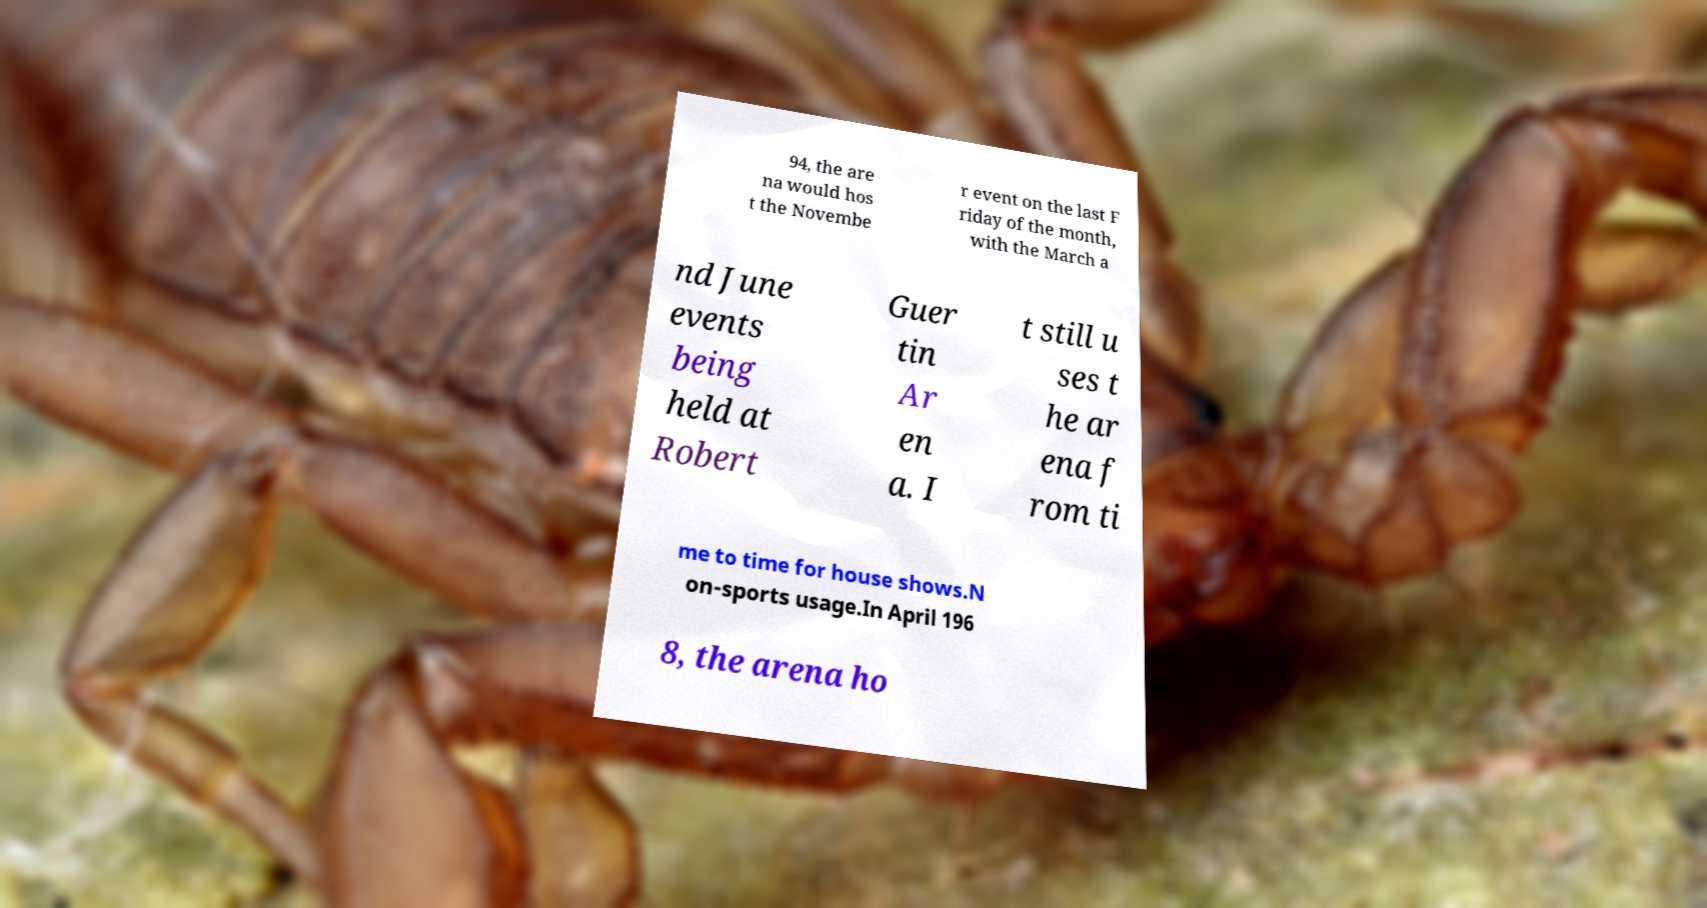For documentation purposes, I need the text within this image transcribed. Could you provide that? 94, the are na would hos t the Novembe r event on the last F riday of the month, with the March a nd June events being held at Robert Guer tin Ar en a. I t still u ses t he ar ena f rom ti me to time for house shows.N on-sports usage.In April 196 8, the arena ho 